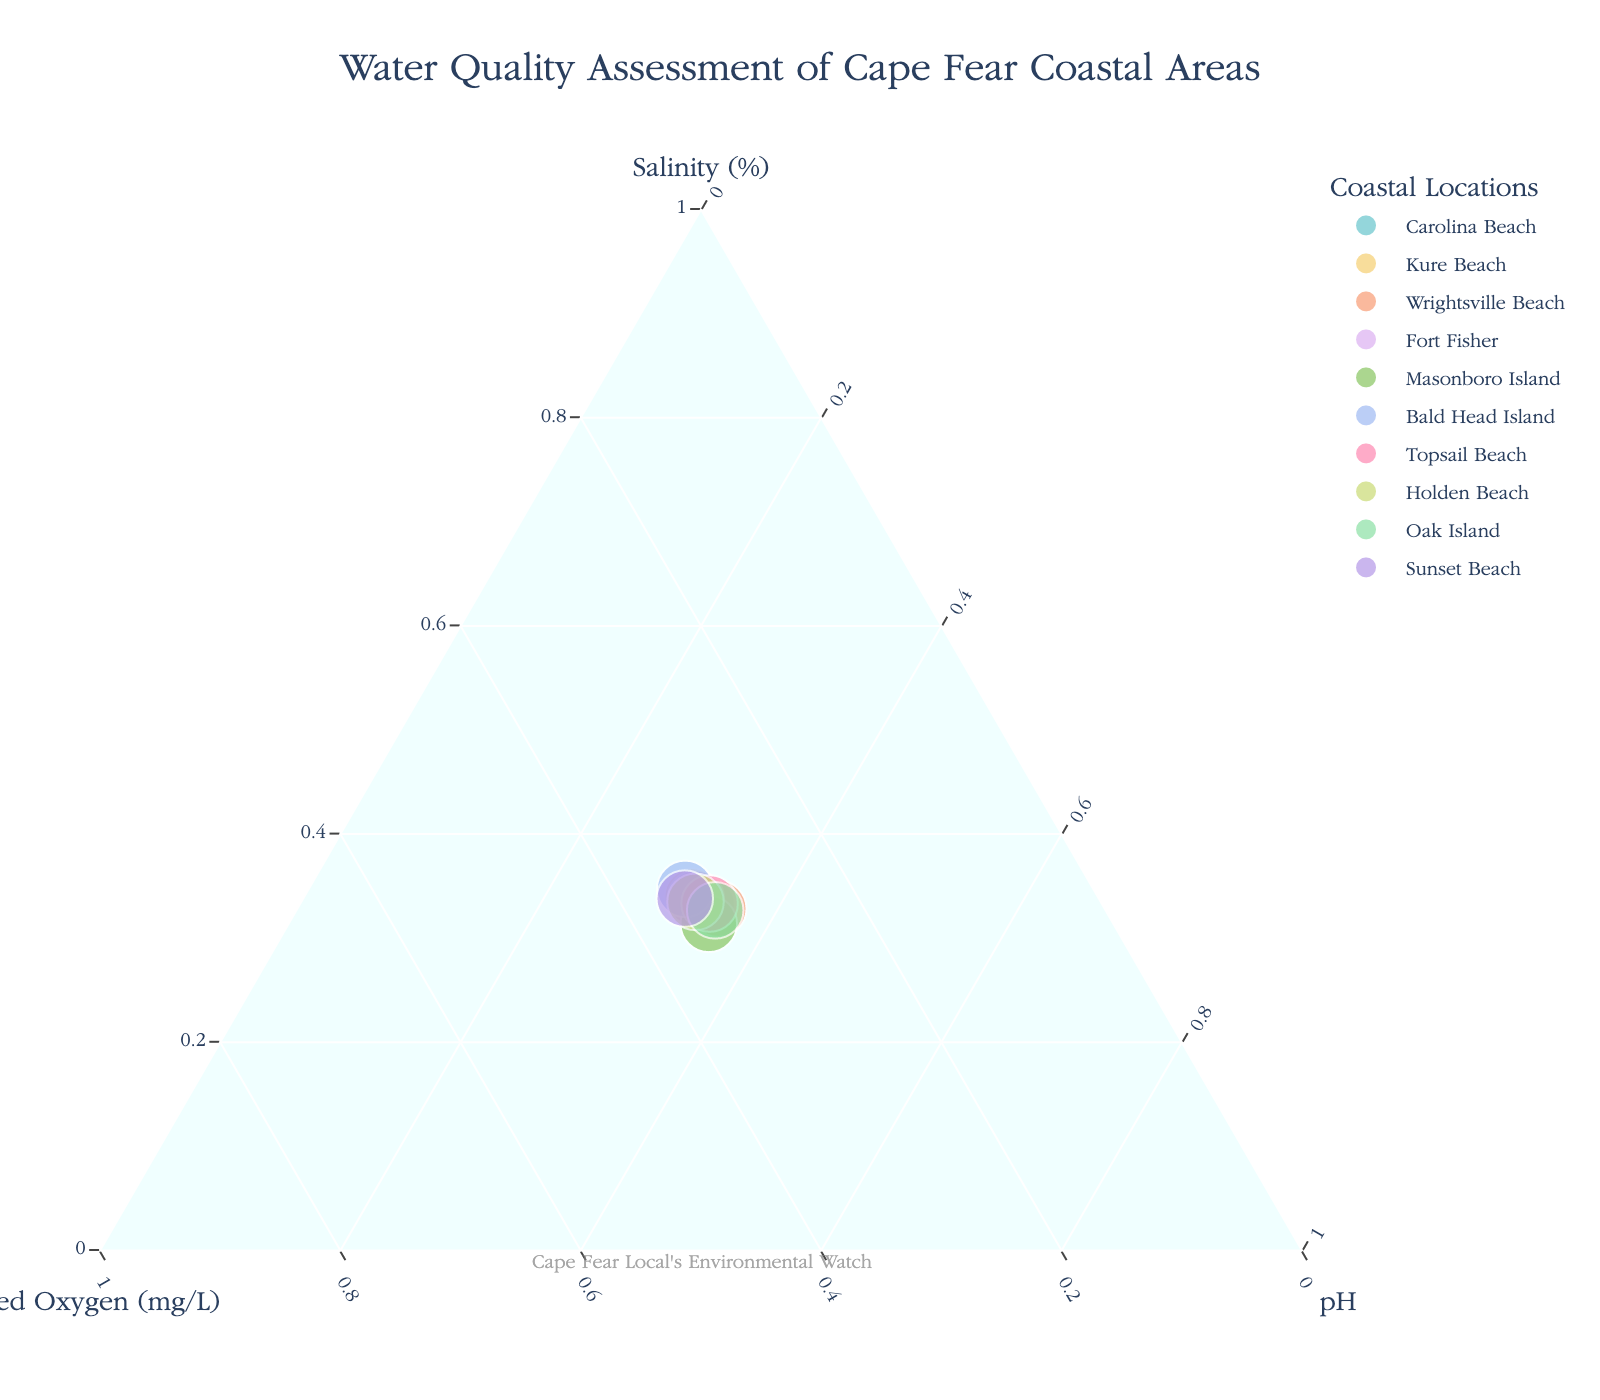What's the title of the plot? The title is usually displayed at the top center of the plot. In this case, based on the provided data and code, the title should be about assessing water quality.
Answer: Water Quality Assessment of Cape Fear Coastal Areas How many coastal locations are represented in the plot? Each data point in the ternary plot corresponds to a coastal location. By counting the number of data points or referring to the legend, we can determine the number of locations. According to the data, there are 10 locations.
Answer: 10 Which location has the highest normalized salinity value? In a ternary plot, the point closest to the Salinity (%) axis with the highest a-axis value corresponds to the highest normalized salinity. By examining the plot, we identify Bald Head Island has the highest value.
Answer: Bald Head Island How does Kure Beach's dissolved oxygen level compare to Wrightsville Beach? To compare dissolved oxygen levels, refer to the position on the b-axis. Kure Beach will be closer to the top (higher values of Dissolved Oxygen) compared to Wrightsville Beach. Kure Beach has 7.2 mg/L and Wrightsville Beach has 6.5 mg/L.
Answer: Kure Beach has higher dissolved oxygen Which location shows the lowest pH level? The point closest to the pH axis with the highest c-axis value in normalized form corresponds to the lowest pH level. By identifying the position on the plot, see that Bald Head Island has the lowest pH.
Answer: Bald Head Island What's the average normalized value of dissolved oxygen for the locations? To find the average, sum up the normalized values of dissolved oxygen for all locations and divide by the number of locations. Refer to the data code for the normalization steps: dissolved oxygen levels are first summed, and each value is divided by this sum. Calculate (0.085, 0.09, 0.081, 0.087, 0.085, 0.091, 0.084, 0.088, 0.081, 0.093), total of 0.865 ÷ 10.
Answer: 0.0865 Are there any locations where all parameters (Salinity, Dissolved Oxygen, pH) are roughly equal? To find locations where normalized values are nearly equal, look for points near the center of the ternary plot where a, b, and c values are close to each other. Upon visual inspection, no such locations are identified as all show variations.
Answer: No Do Carolina Beach and Topsail Beach have similar water quality parameters? Compare the positions of Carolina Beach and Topsail Beach across the ternary plot axes. If their positions are close or overlap, they have similar parameters. Both have similar positions, indicating close values (with slight variations).
Answer: Yes Which beach has the highest overall pH value? By examining the c-axis values, the highest overall pH value will be closest to the pH axis and furthest from the origin. Masonboro Island, with an 8.3 value, is the furthest on the c-axis.
Answer: Masonboro Island 